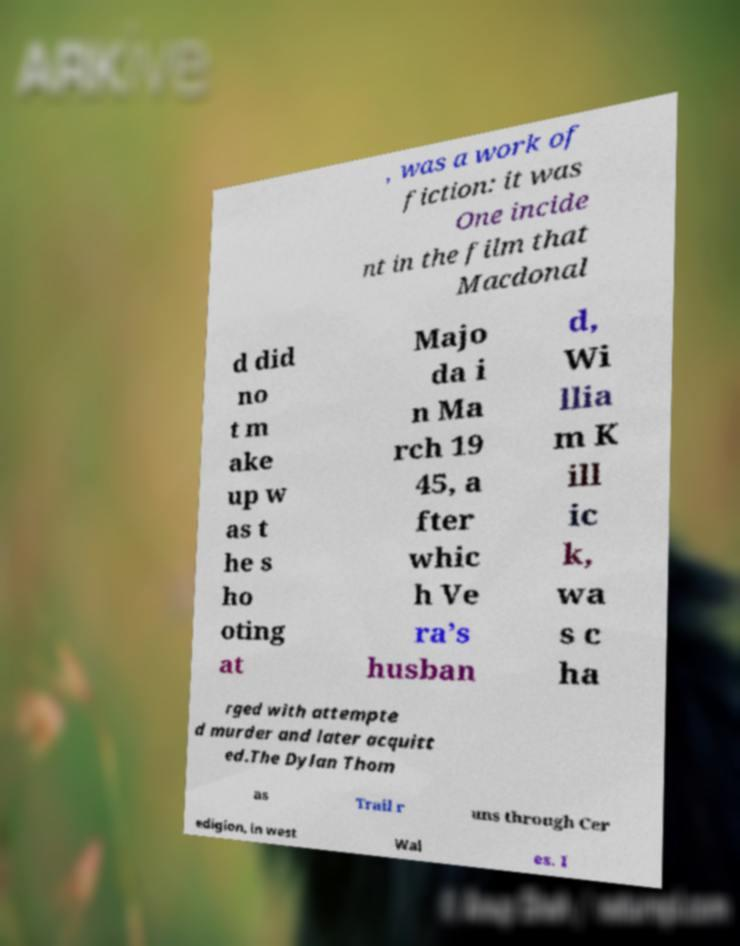I need the written content from this picture converted into text. Can you do that? , was a work of fiction: it was One incide nt in the film that Macdonal d did no t m ake up w as t he s ho oting at Majo da i n Ma rch 19 45, a fter whic h Ve ra’s husban d, Wi llia m K ill ic k, wa s c ha rged with attempte d murder and later acquitt ed.The Dylan Thom as Trail r uns through Cer edigion, in west Wal es. I 